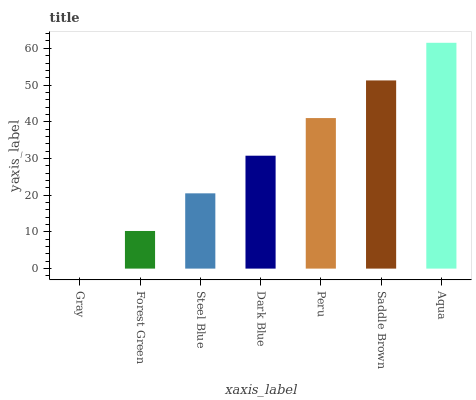Is Gray the minimum?
Answer yes or no. Yes. Is Aqua the maximum?
Answer yes or no. Yes. Is Forest Green the minimum?
Answer yes or no. No. Is Forest Green the maximum?
Answer yes or no. No. Is Forest Green greater than Gray?
Answer yes or no. Yes. Is Gray less than Forest Green?
Answer yes or no. Yes. Is Gray greater than Forest Green?
Answer yes or no. No. Is Forest Green less than Gray?
Answer yes or no. No. Is Dark Blue the high median?
Answer yes or no. Yes. Is Dark Blue the low median?
Answer yes or no. Yes. Is Peru the high median?
Answer yes or no. No. Is Forest Green the low median?
Answer yes or no. No. 